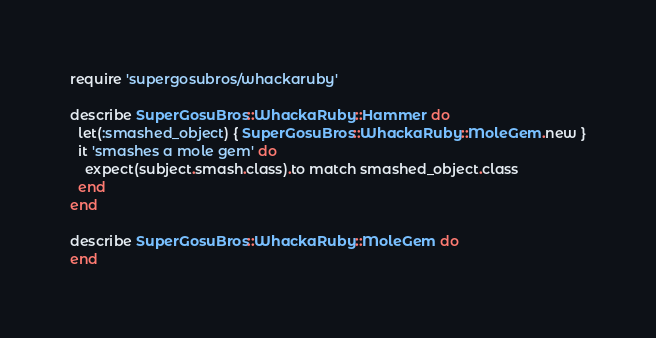<code> <loc_0><loc_0><loc_500><loc_500><_Ruby_>require 'supergosubros/whackaruby'

describe SuperGosuBros::WhackaRuby::Hammer do
  let(:smashed_object) { SuperGosuBros::WhackaRuby::MoleGem.new }
  it 'smashes a mole gem' do
    expect(subject.smash.class).to match smashed_object.class
  end
end

describe SuperGosuBros::WhackaRuby::MoleGem do
end
</code> 